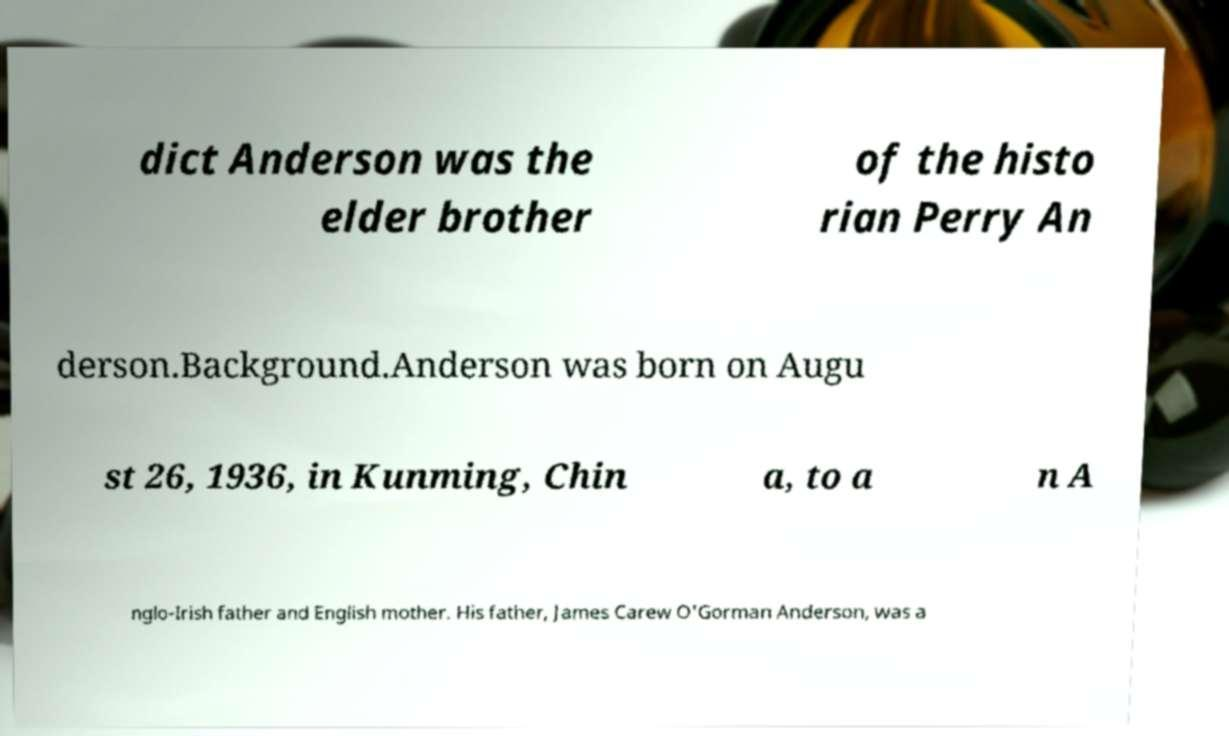Can you read and provide the text displayed in the image?This photo seems to have some interesting text. Can you extract and type it out for me? dict Anderson was the elder brother of the histo rian Perry An derson.Background.Anderson was born on Augu st 26, 1936, in Kunming, Chin a, to a n A nglo-Irish father and English mother. His father, James Carew O'Gorman Anderson, was a 